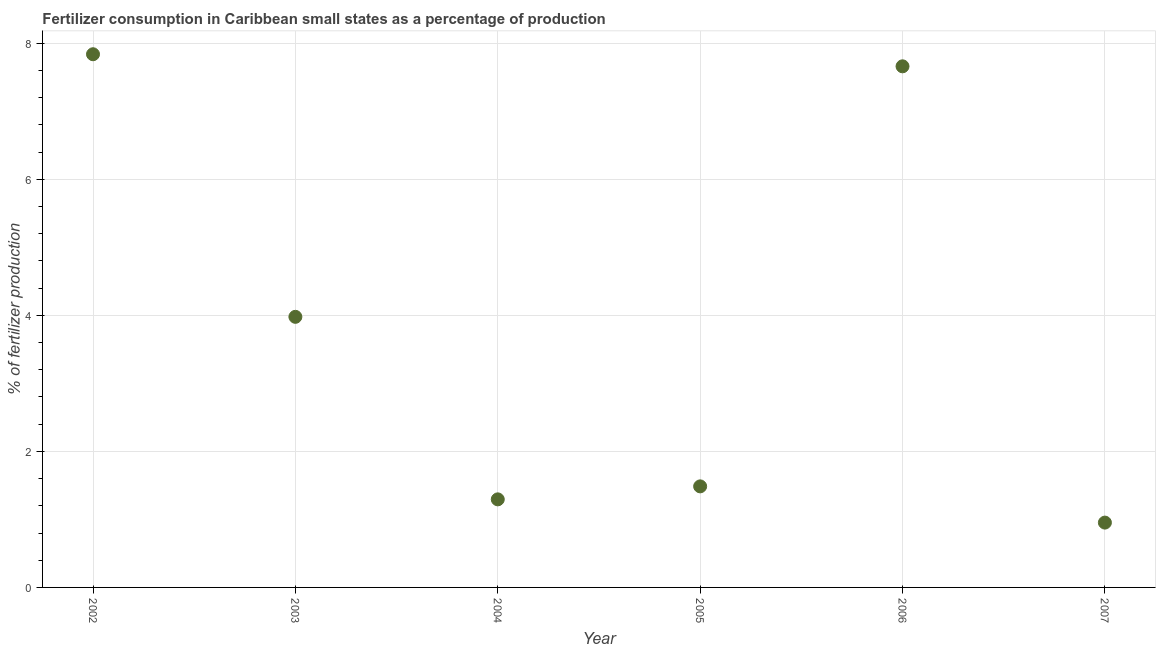What is the amount of fertilizer consumption in 2006?
Your answer should be very brief. 7.66. Across all years, what is the maximum amount of fertilizer consumption?
Keep it short and to the point. 7.84. Across all years, what is the minimum amount of fertilizer consumption?
Provide a short and direct response. 0.95. In which year was the amount of fertilizer consumption maximum?
Your answer should be very brief. 2002. In which year was the amount of fertilizer consumption minimum?
Your response must be concise. 2007. What is the sum of the amount of fertilizer consumption?
Make the answer very short. 23.21. What is the difference between the amount of fertilizer consumption in 2003 and 2004?
Provide a succinct answer. 2.68. What is the average amount of fertilizer consumption per year?
Your response must be concise. 3.87. What is the median amount of fertilizer consumption?
Your response must be concise. 2.73. In how many years, is the amount of fertilizer consumption greater than 0.4 %?
Keep it short and to the point. 6. What is the ratio of the amount of fertilizer consumption in 2005 to that in 2006?
Make the answer very short. 0.19. What is the difference between the highest and the second highest amount of fertilizer consumption?
Your response must be concise. 0.18. What is the difference between the highest and the lowest amount of fertilizer consumption?
Offer a terse response. 6.89. In how many years, is the amount of fertilizer consumption greater than the average amount of fertilizer consumption taken over all years?
Your response must be concise. 3. Does the amount of fertilizer consumption monotonically increase over the years?
Offer a terse response. No. Does the graph contain any zero values?
Keep it short and to the point. No. Does the graph contain grids?
Offer a terse response. Yes. What is the title of the graph?
Provide a short and direct response. Fertilizer consumption in Caribbean small states as a percentage of production. What is the label or title of the X-axis?
Your answer should be very brief. Year. What is the label or title of the Y-axis?
Keep it short and to the point. % of fertilizer production. What is the % of fertilizer production in 2002?
Give a very brief answer. 7.84. What is the % of fertilizer production in 2003?
Provide a short and direct response. 3.98. What is the % of fertilizer production in 2004?
Your answer should be compact. 1.29. What is the % of fertilizer production in 2005?
Provide a short and direct response. 1.49. What is the % of fertilizer production in 2006?
Provide a short and direct response. 7.66. What is the % of fertilizer production in 2007?
Your answer should be compact. 0.95. What is the difference between the % of fertilizer production in 2002 and 2003?
Provide a succinct answer. 3.86. What is the difference between the % of fertilizer production in 2002 and 2004?
Ensure brevity in your answer.  6.54. What is the difference between the % of fertilizer production in 2002 and 2005?
Your answer should be very brief. 6.35. What is the difference between the % of fertilizer production in 2002 and 2006?
Your response must be concise. 0.18. What is the difference between the % of fertilizer production in 2002 and 2007?
Make the answer very short. 6.89. What is the difference between the % of fertilizer production in 2003 and 2004?
Give a very brief answer. 2.68. What is the difference between the % of fertilizer production in 2003 and 2005?
Ensure brevity in your answer.  2.49. What is the difference between the % of fertilizer production in 2003 and 2006?
Offer a very short reply. -3.68. What is the difference between the % of fertilizer production in 2003 and 2007?
Offer a very short reply. 3.02. What is the difference between the % of fertilizer production in 2004 and 2005?
Provide a short and direct response. -0.19. What is the difference between the % of fertilizer production in 2004 and 2006?
Make the answer very short. -6.37. What is the difference between the % of fertilizer production in 2004 and 2007?
Keep it short and to the point. 0.34. What is the difference between the % of fertilizer production in 2005 and 2006?
Give a very brief answer. -6.18. What is the difference between the % of fertilizer production in 2005 and 2007?
Give a very brief answer. 0.53. What is the difference between the % of fertilizer production in 2006 and 2007?
Provide a succinct answer. 6.71. What is the ratio of the % of fertilizer production in 2002 to that in 2003?
Make the answer very short. 1.97. What is the ratio of the % of fertilizer production in 2002 to that in 2004?
Give a very brief answer. 6.05. What is the ratio of the % of fertilizer production in 2002 to that in 2005?
Offer a terse response. 5.28. What is the ratio of the % of fertilizer production in 2002 to that in 2006?
Make the answer very short. 1.02. What is the ratio of the % of fertilizer production in 2002 to that in 2007?
Make the answer very short. 8.22. What is the ratio of the % of fertilizer production in 2003 to that in 2004?
Make the answer very short. 3.07. What is the ratio of the % of fertilizer production in 2003 to that in 2005?
Provide a succinct answer. 2.68. What is the ratio of the % of fertilizer production in 2003 to that in 2006?
Provide a succinct answer. 0.52. What is the ratio of the % of fertilizer production in 2003 to that in 2007?
Your answer should be very brief. 4.17. What is the ratio of the % of fertilizer production in 2004 to that in 2005?
Offer a terse response. 0.87. What is the ratio of the % of fertilizer production in 2004 to that in 2006?
Provide a succinct answer. 0.17. What is the ratio of the % of fertilizer production in 2004 to that in 2007?
Your response must be concise. 1.36. What is the ratio of the % of fertilizer production in 2005 to that in 2006?
Give a very brief answer. 0.19. What is the ratio of the % of fertilizer production in 2005 to that in 2007?
Provide a succinct answer. 1.56. What is the ratio of the % of fertilizer production in 2006 to that in 2007?
Ensure brevity in your answer.  8.04. 